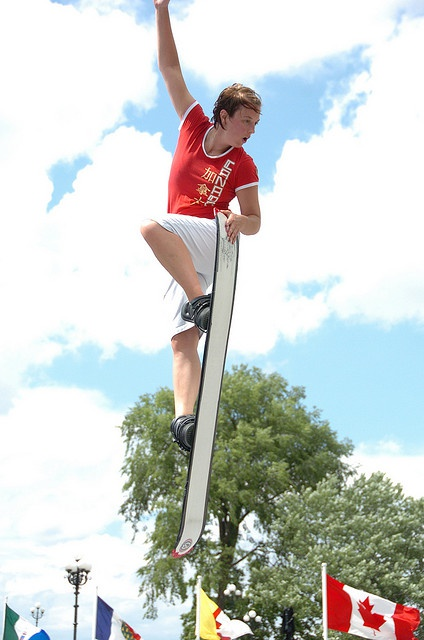Describe the objects in this image and their specific colors. I can see people in white, gray, brown, and darkgray tones and snowboard in white, lightgray, gray, and darkgray tones in this image. 